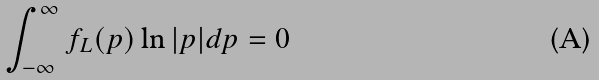<formula> <loc_0><loc_0><loc_500><loc_500>\int ^ { \infty } _ { - \infty } f _ { L } ( p ) \ln | p | d p = 0</formula> 